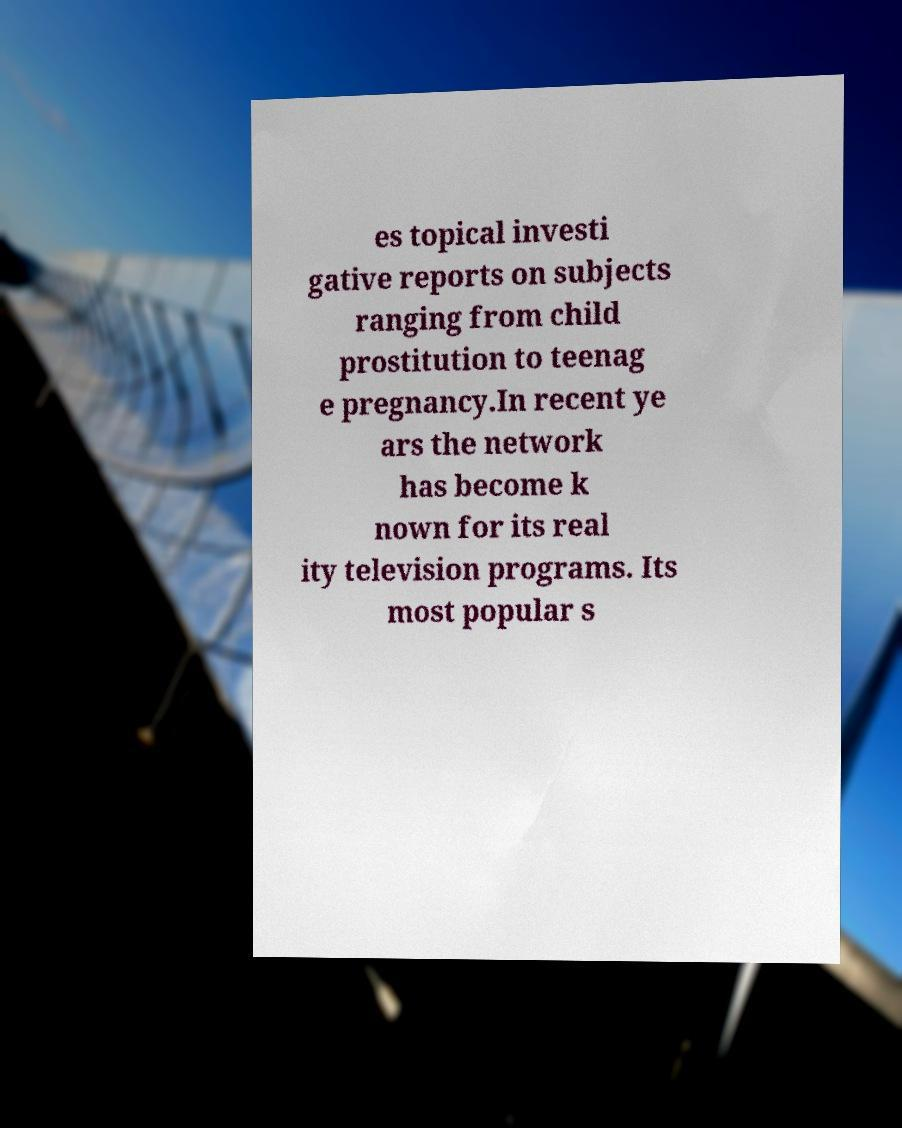What messages or text are displayed in this image? I need them in a readable, typed format. es topical investi gative reports on subjects ranging from child prostitution to teenag e pregnancy.In recent ye ars the network has become k nown for its real ity television programs. Its most popular s 